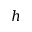Convert formula to latex. <formula><loc_0><loc_0><loc_500><loc_500>h</formula> 